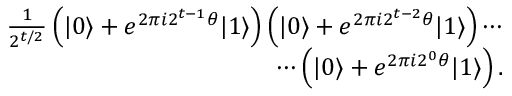Convert formula to latex. <formula><loc_0><loc_0><loc_500><loc_500>\begin{array} { r } { \frac { 1 } { 2 ^ { t / 2 } } \left ( | 0 \rangle + e ^ { 2 \pi i 2 ^ { t - 1 } \theta } | 1 \rangle \right ) \left ( | 0 \rangle + e ^ { 2 \pi i 2 ^ { t - 2 } \theta } | 1 \rangle \right ) \cdots } \\ { \cdots \left ( | 0 \rangle + e ^ { 2 \pi i 2 ^ { 0 } \theta } | 1 \rangle \right ) . } \end{array}</formula> 